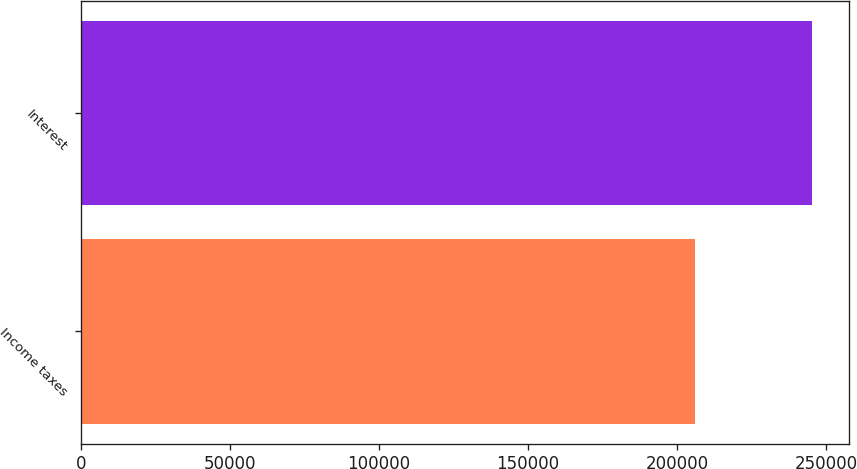<chart> <loc_0><loc_0><loc_500><loc_500><bar_chart><fcel>Income taxes<fcel>Interest<nl><fcel>205955<fcel>245325<nl></chart> 